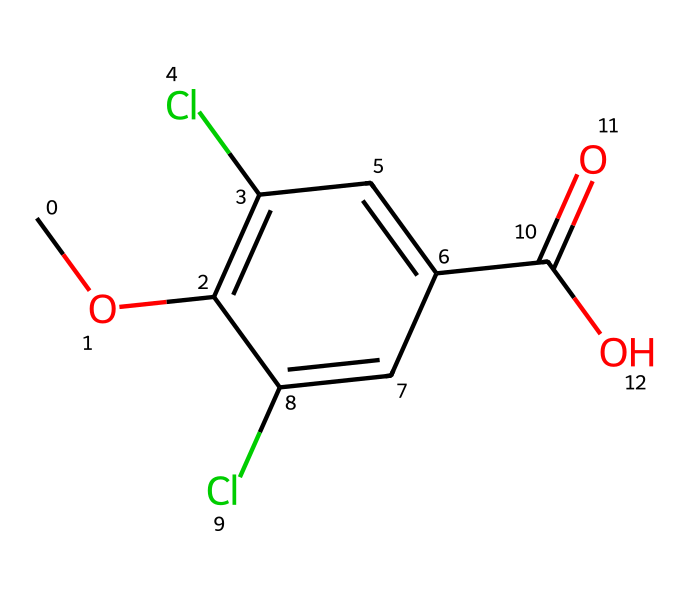What is the chemical name of this compound? The chemical structure corresponds to dicamba, which is a well-known herbicide used for controlling broadleaf weeds.
Answer: dicamba How many chlorine atoms are present in this structure? From the provided SMILES representation, there are two 'Cl' symbols, indicating the presence of two chlorine atoms in the chemical structure.
Answer: two What functional group is indicated by the ‘C(=O)O’ in the structure? The ‘C(=O)O’ part of the structure represents a carboxylic acid functional group, which consists of a carbonyl (C=O) and a hydroxyl (O-H) group.
Answer: carboxylic acid What type of herbicide is dicamba classified as? Dicamba is classified as a synthetic auxin herbicide, which mimics natural plant hormones to disrupt growth in target weeds.
Answer: synthetic auxin How many carbon atoms make up this molecule? By analyzing the SMILES, we can count the carbon atoms represented. The structure contains a total of 9 carbon atoms in various functional groups.
Answer: nine What type of chemical bonds are predominantly found in dicamba? The SMILES representation illustrates that dicamba has mainly covalent bonds, which are formed between the atoms in the structure.
Answer: covalent bonds What characteristic of dicamba makes it effective for use in genetically modified crops? Dicamba's effectiveness lies in its ability to target specific weed species while being less harmful to certain genetically modified crops that are tolerant to its effects.
Answer: selectivity 